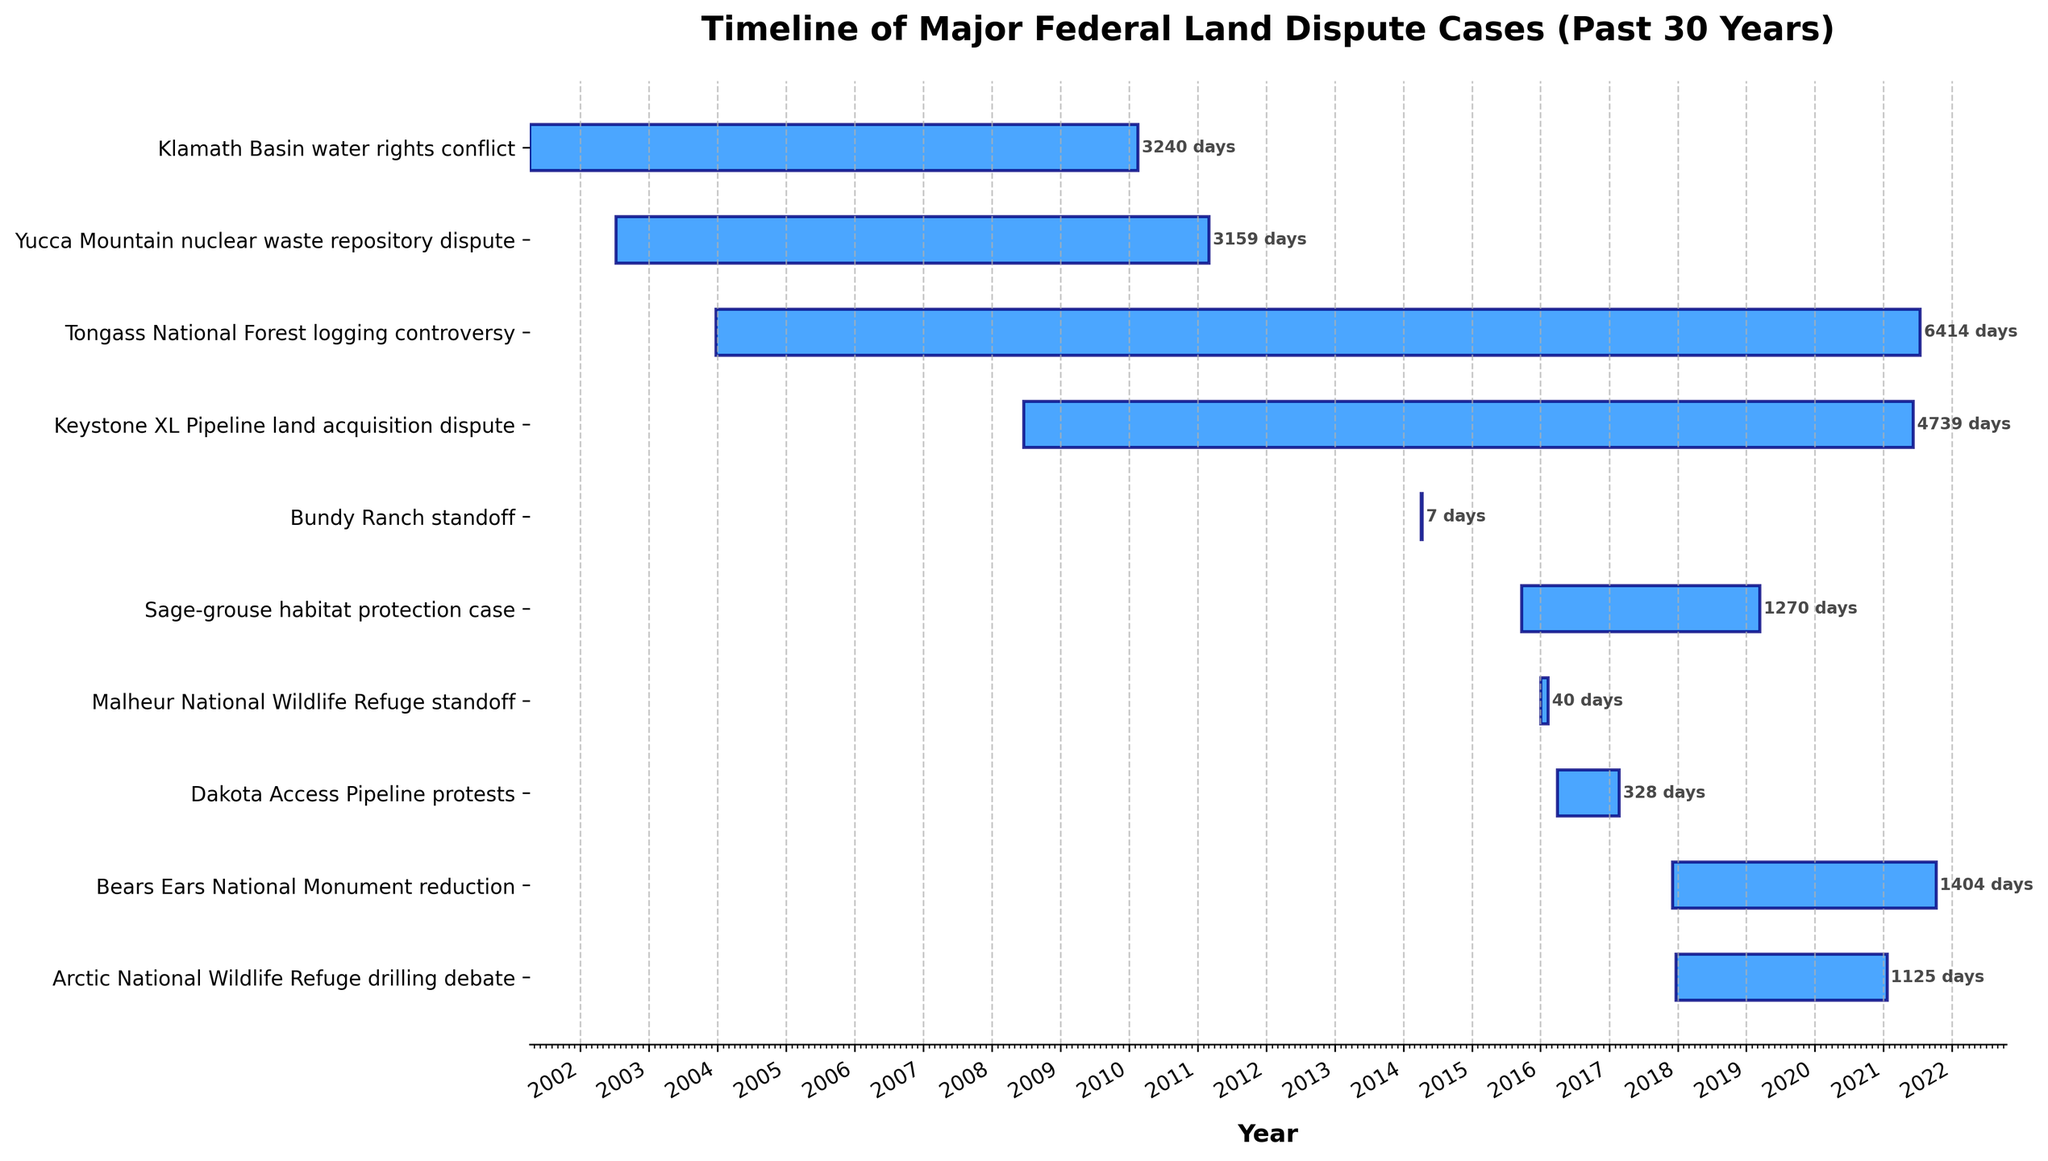What's the title of the figure? The title is written at the top of the figure, clearly stating its description. The title helps to quickly understand what the figure represents.
Answer: Timeline of Major Federal Land Dispute Cases (Past 30 Years) What is the y-axis representing? By reading the labels along the y-axis, it is evident that each label corresponds to the name of a federal land dispute case.
Answer: Federal land dispute cases Which case had the longest duration and how many days did it last? Look at the duration (length of the bars) of each case and identify which one is the longest. Then check the duration label next to the bar.
Answer: Tongass National Forest logging controversy, 6846 days Which case had the shortest duration and how many days did it last? Look at the duration (length of the bars) of each case and identify which one is the shortest. Then check the duration label next to the bar.
Answer: Bundy Ranch standoff, 7 days How many cases lasted over 1000 days? Examine each bar to see its duration and count the number of cases where the duration is greater than 1000 days.
Answer: 5 cases What is the total duration of the Malheur National Wildlife Refuge standoff? Find the bar corresponding to this case and read the duration label next to it.
Answer: 40 days Which case started first and which started last? Check the start date of each case by looking at the "left" ends of the bars. The leftmost bar started first and the rightmost bar started last.
Answer: Klamath Basin water rights conflict (first), Bears Ears National Monument reduction (last) Arrange the cases starting from the one with the earliest end date to the one with the latest end date. Order the bars based on their end dates from left to right. The one that ends the earliest is on the left and so on.
Answer: Klamath Basin water rights conflict, Yucca Mountain nuclear waste repository dispute, Tongass National Forest logging controversy, Sage-grouse habitat protection case, Dakota Access Pipeline protests, Keystone XL Pipeline land acquisition dispute, Arctic National Wildlife Refuge drilling debate, Bears Ears National Monument reduction Overlapping periods: Which cases were happening during the same time period in April 2017? Identify bars with overlapping periods for April 2017 by examining the timeline provided in the figure.
Answer: Dakota Access Pipeline protests, Keystone XL Pipeline land acquisition dispute Which cases had durations that crossed the threshold of multiple presidential terms? By matching the case durations with U.S. presidential terms, identify which cases spanned more than one presidential administration.
Answer: Yucca Mountain nuclear waste repository dispute, Keystone XL Pipeline land acquisition dispute, Tongass National Forest logging controversy 